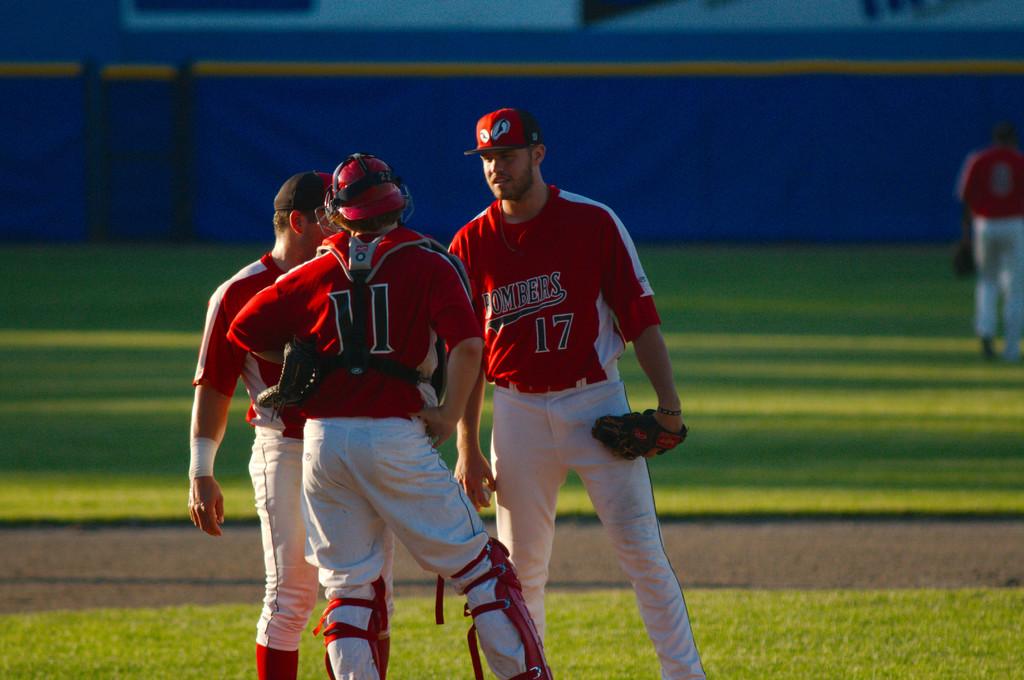What is the jersey number who's standing in front?
Your answer should be compact. 11. What color jersey are they wearing?
Your response must be concise. Answering does not require reading text in the image. 